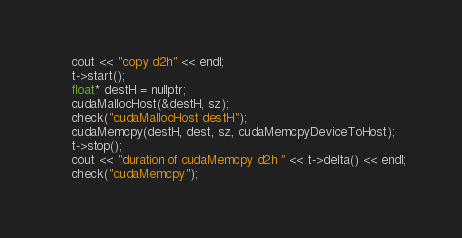Convert code to text. <code><loc_0><loc_0><loc_500><loc_500><_Cuda_>	cout << "copy d2h" << endl;
	t->start();
	float* destH = nullptr;
	cudaMallocHost(&destH, sz);
	check("cudaMallocHost destH");
	cudaMemcpy(destH, dest, sz, cudaMemcpyDeviceToHost);
	t->stop();
	cout << "duration of cudaMemcpy d2h " << t->delta() << endl;
	check("cudaMemcpy");
</code> 